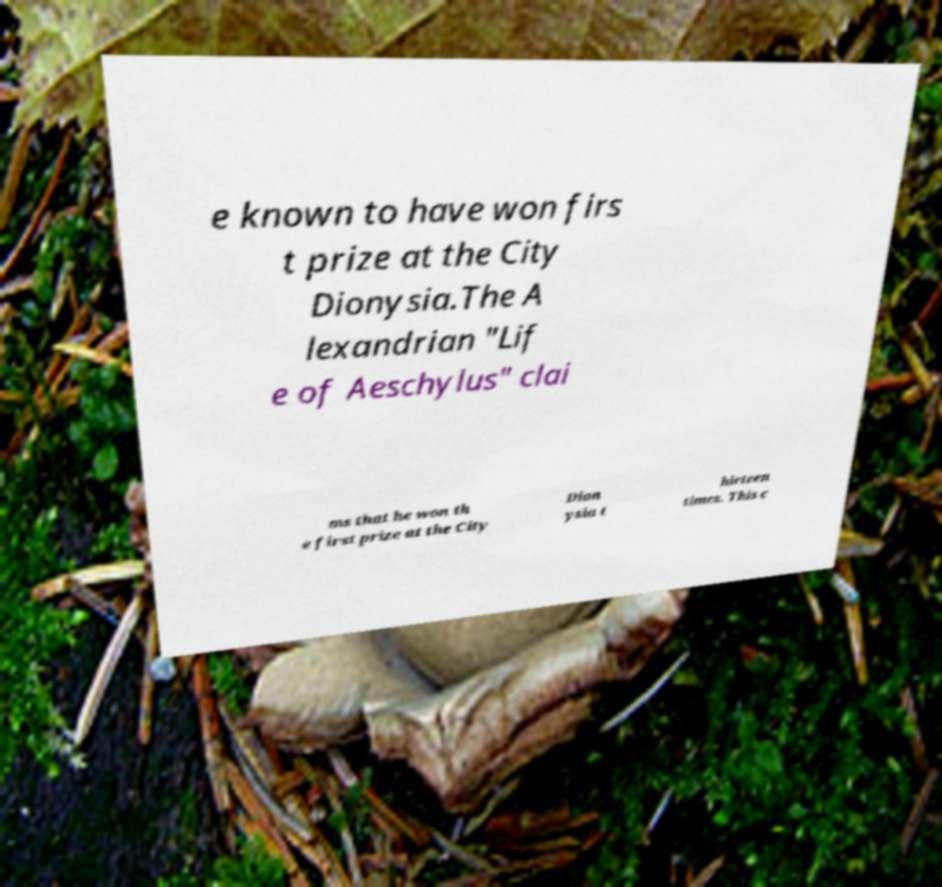Could you extract and type out the text from this image? e known to have won firs t prize at the City Dionysia.The A lexandrian "Lif e of Aeschylus" clai ms that he won th e first prize at the City Dion ysia t hirteen times. This c 